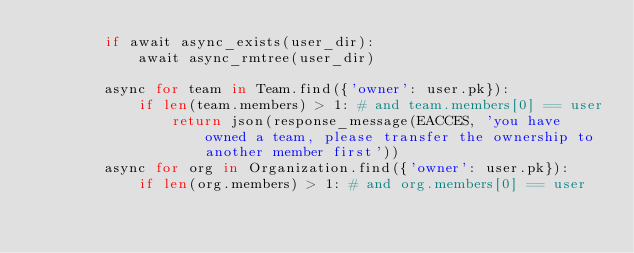<code> <loc_0><loc_0><loc_500><loc_500><_Python_>        if await async_exists(user_dir):
            await async_rmtree(user_dir)

        async for team in Team.find({'owner': user.pk}):
            if len(team.members) > 1: # and team.members[0] == user
                return json(response_message(EACCES, 'you have owned a team, please transfer the ownership to another member first'))
        async for org in Organization.find({'owner': user.pk}):
            if len(org.members) > 1: # and org.members[0] == user</code> 